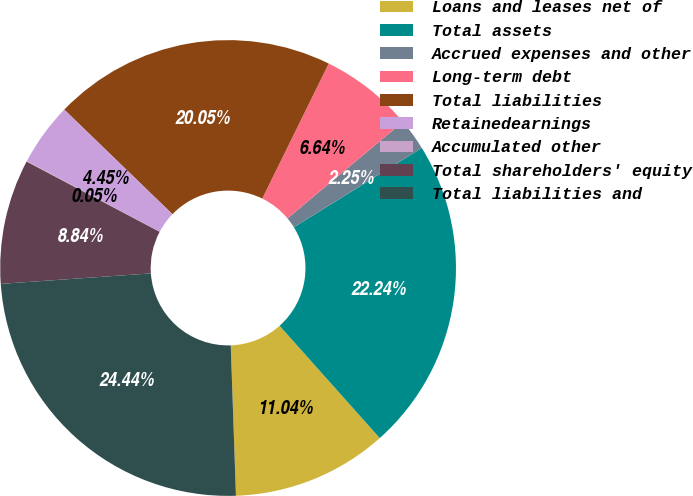Convert chart. <chart><loc_0><loc_0><loc_500><loc_500><pie_chart><fcel>Loans and leases net of<fcel>Total assets<fcel>Accrued expenses and other<fcel>Long-term debt<fcel>Total liabilities<fcel>Retainedearnings<fcel>Accumulated other<fcel>Total shareholders' equity<fcel>Total liabilities and<nl><fcel>11.04%<fcel>22.24%<fcel>2.25%<fcel>6.64%<fcel>20.05%<fcel>4.45%<fcel>0.05%<fcel>8.84%<fcel>24.44%<nl></chart> 